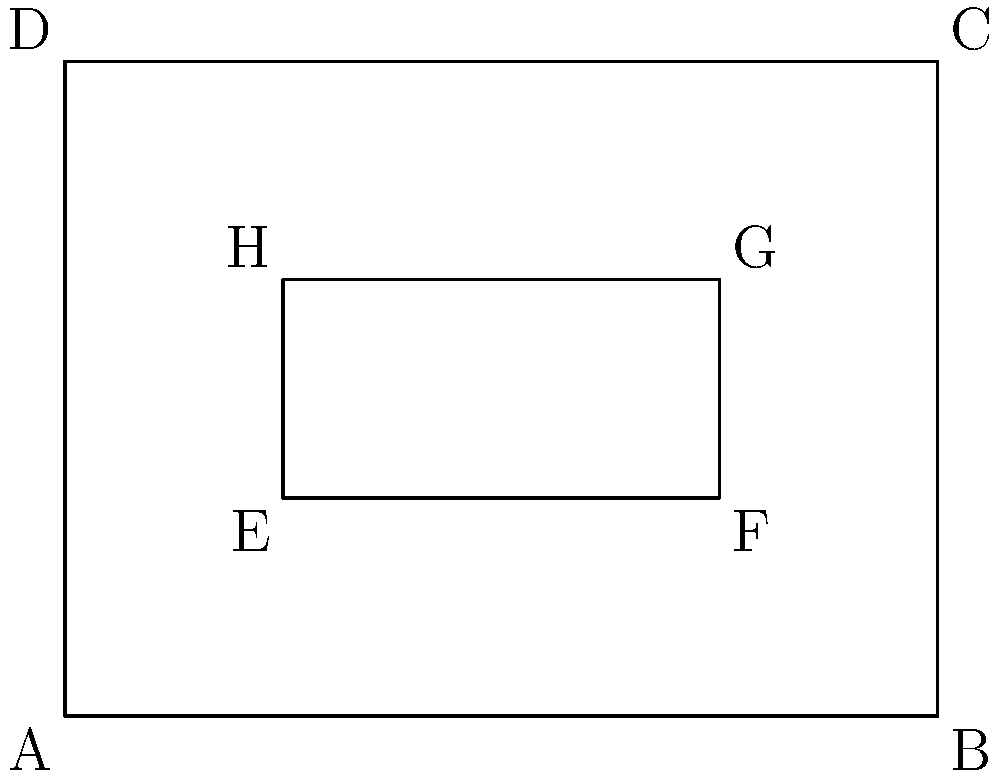In traditional Korean architecture, the main hall of a hanok (traditional Korean house) often features a raised wooden floor area called maru. The diagram shows the floor plan of a rectangular maru (ABCD) with a smaller rectangular area (EFGH) representing a decorative inlay pattern. If EFGH is congruent to a scaled-down version of ABCD, what is the ratio of the area of EFGH to the area of ABCD? Let's approach this step-by-step:

1) For rectangles to be congruent (same shape), they must have the same ratio of length to width.

2) Let's denote:
   AB = length of ABCD = l
   AD = width of ABCD = w
   EF = length of EFGH = x
   EH = width of EFGH = y

3) For congruence: $\frac{l}{w} = \frac{x}{y}$

4) From the diagram, we can see:
   EF = AB - 2 = l - 2
   EH = AD - 2 = w - 2

5) Substituting into the congruence equation:
   $\frac{l}{w} = \frac{l-2}{w-2}$

6) Cross multiplying:
   $l(w-2) = w(l-2)$
   $lw - 2l = lw - 2w$
   $-2l = -2w$
   $l = w$

7) This means ABCD is a square. Let's say its side length is s.
   Then, EFGH has side length s-2.

8) The ratio of areas will be:
   $\frac{\text{Area of EFGH}}{\text{Area of ABCD}} = \frac{(s-2)^2}{s^2} = (\frac{s-2}{s})^2 = (1-\frac{2}{s})^2$

9) From the diagram, we can see that s = 4 (as AB = 4 units)

10) Therefore, the ratio is:
    $(\frac{4-2}{4})^2 = (\frac{1}{2})^2 = \frac{1}{4}$
Answer: 1:4 